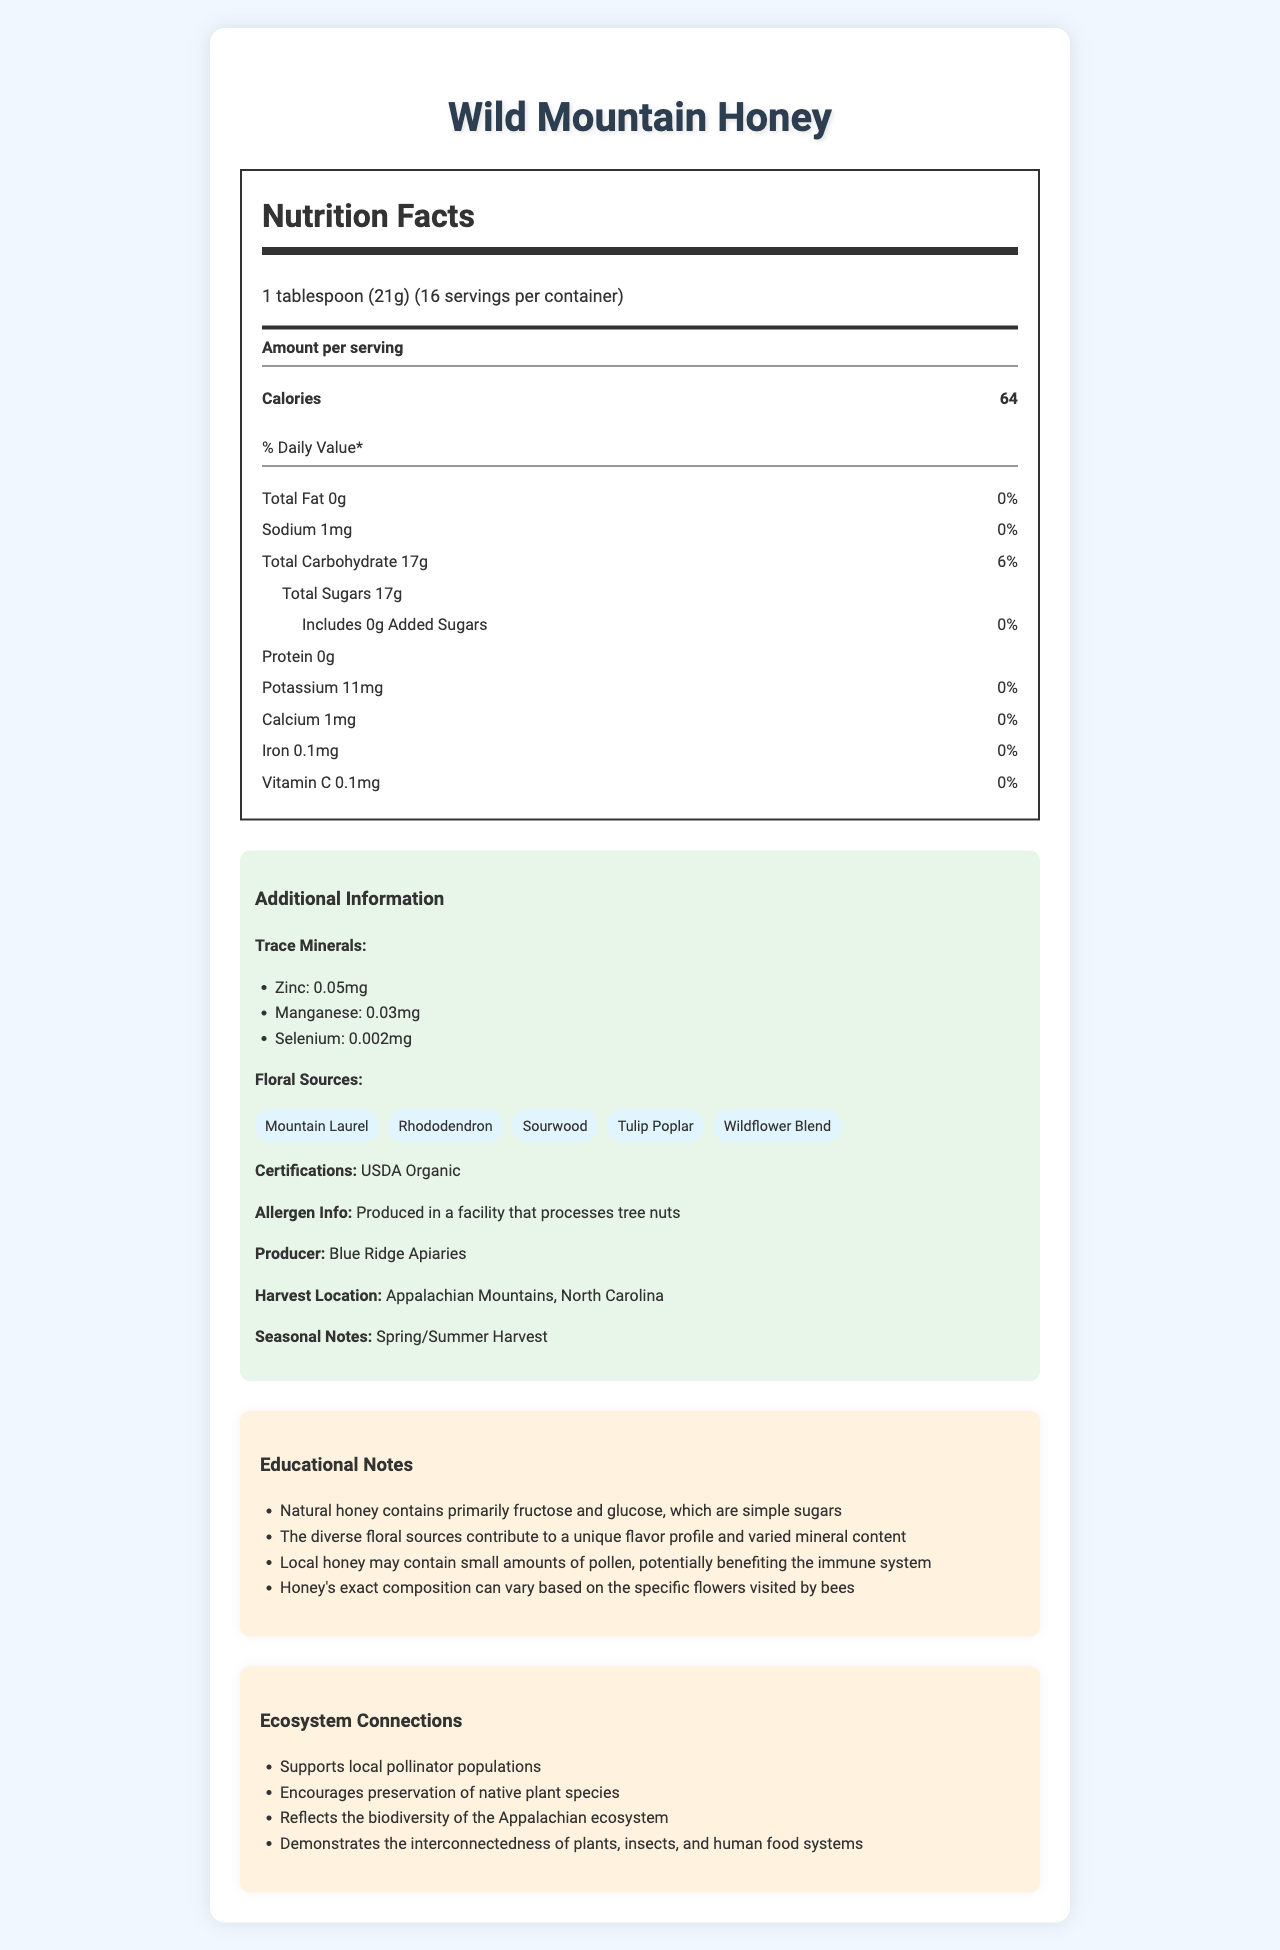What is the serving size for Wild Mountain Honey? The serving size is stated at the top of the nutrition label as "1 tablespoon (21g)".
Answer: 1 tablespoon (21g) How many calories are there per serving of Wild Mountain Honey? The document states that there are 64 calories per serving.
Answer: 64 Does the Wild Mountain Honey contain any added sugars? The nutrition label specifies that the honey includes 0g of added sugars.
Answer: No List at least two trace minerals found in Wild Mountain Honey. The additional information section lists Zinc (0.05mg) and Manganese (0.03mg) as trace minerals.
Answer: Zinc, Manganese Which floral sources contribute to the flavor profile of this honey? The document lists these floral sources in the additional information section.
Answer: Mountain Laurel, Rhododendron, Sourwood, Tulip Poplar, Wildflower Blend What certification does the Wild Mountain Honey have? A. Certified Organic B. USDA Organic C. Fair Trade D. Non-GMO Project The document mentions "USDA Organic" in the additional information section.
Answer: B. USDA Organic Where is Wild Mountain Honey harvested? A. Blue Ridge Mountains B. Rocky Mountains C. Appalachian Mountains D. Cascade Mountains The harvest location is specified as "Appalachian Mountains, North Carolina".
Answer: C. Appalachian Mountains Is the Wild Mountain Honey produced in a facility that processes tree nuts? The additional information section mentions that it is produced in a facility that processes tree nuts.
Answer: Yes Does Wild Mountain Honey contain protein? The nutrition label shows 0g of protein per serving.
Answer: No Summarize the main idea of the document. The document is comprehensive, covering nutritional facts, sources, and holistic details about Wild Mountain Honey, emphasizing its natural benefits and ecological importance.
Answer: The document provides detailed nutritional information for Wild Mountain Honey, including serving size, calories, carbohydrates, sugars, trace minerals, and floral sources. Additionally, it highlights the honey’s USDA organic certification, allergen information, local producer details, seasonal notes, and educational insights regarding its natural composition, benefits, and ecosystem connections. What is the total amount of sodium in a serving of Wild Mountain Honey? The nutrition label indicates that there is 1mg of sodium per serving.
Answer: 1mg Does the document mention the specific amount of natural pollen in the honey? The document talks about small amounts of pollen potentially benefiting the immune system but does not specify an exact amount.
Answer: Not enough information How does Wild Mountain Honey contribute to local ecosystems based on the document? The document’s ecosystem connections section lists these contributions, showing the honey's positive impact on the environment.
Answer: Supports local pollinator populations, encourages preservation of native plant species, reflects the biodiversity of the Appalachian ecosystem, demonstrates interconnectedness of plants, insects, and human food systems. How much iron is present in each serving of Wild Mountain Honey? The nutrition label states that each serving contains 0.1mg of iron.
Answer: 0.1mg 